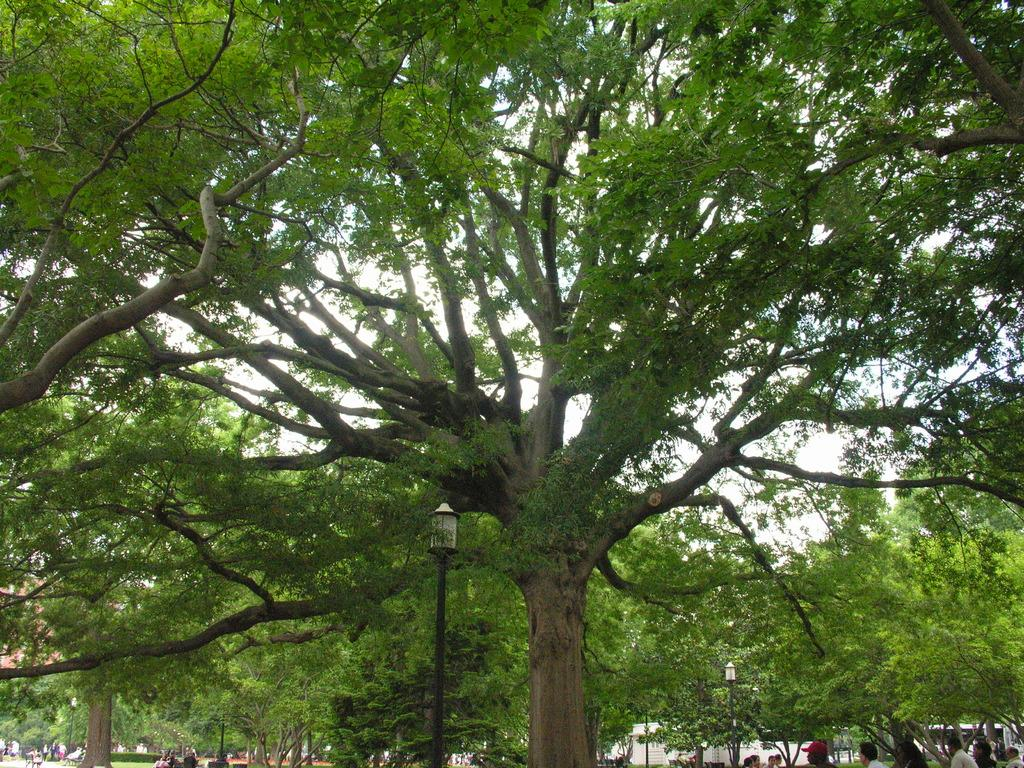How many people are present in the image? There are many people in the image. What are the people wearing? The people are wearing clothes. What type of vegetation can be seen in the image? There are trees and grass in the image. What is the tall, man-made structure in the image? There is a light pole in the image. What part of the natural environment is visible in the image? The sky is visible in the image. What is the opinion of the beast in the image? There is no beast present in the image, so it is not possible to determine its opinion. 